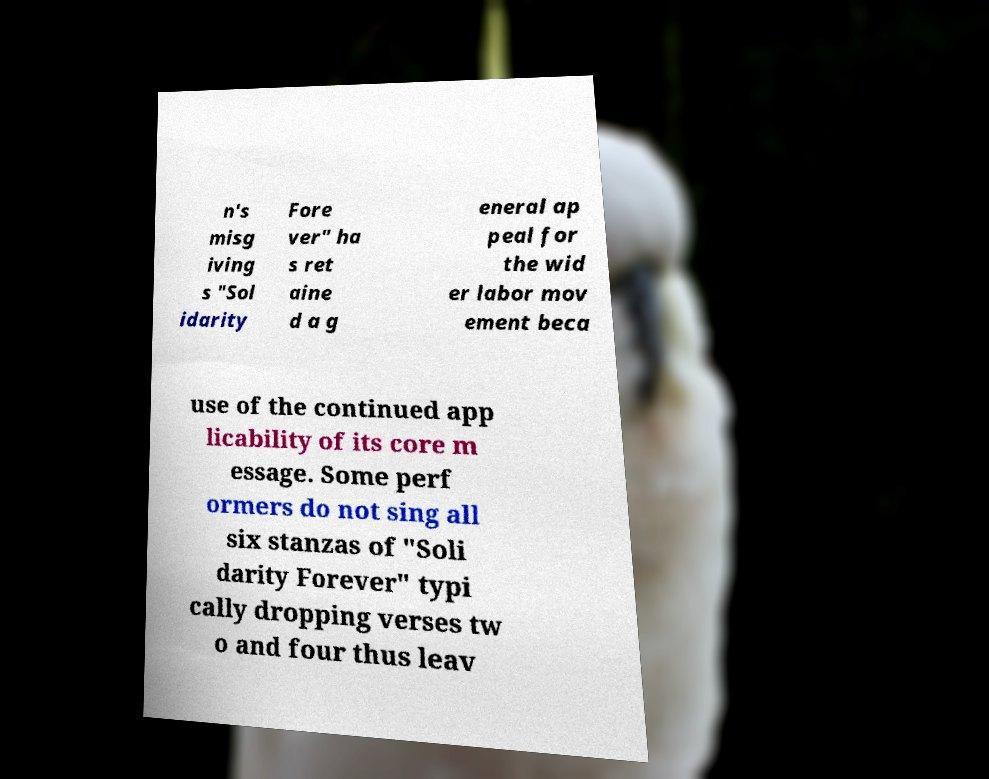For documentation purposes, I need the text within this image transcribed. Could you provide that? n's misg iving s "Sol idarity Fore ver" ha s ret aine d a g eneral ap peal for the wid er labor mov ement beca use of the continued app licability of its core m essage. Some perf ormers do not sing all six stanzas of "Soli darity Forever" typi cally dropping verses tw o and four thus leav 